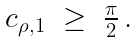Convert formula to latex. <formula><loc_0><loc_0><loc_500><loc_500>\begin{array} { c } c _ { \rho , 1 } \ \geq \ \frac { \pi } { 2 } \, . \end{array}</formula> 